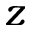<formula> <loc_0><loc_0><loc_500><loc_500>z</formula> 